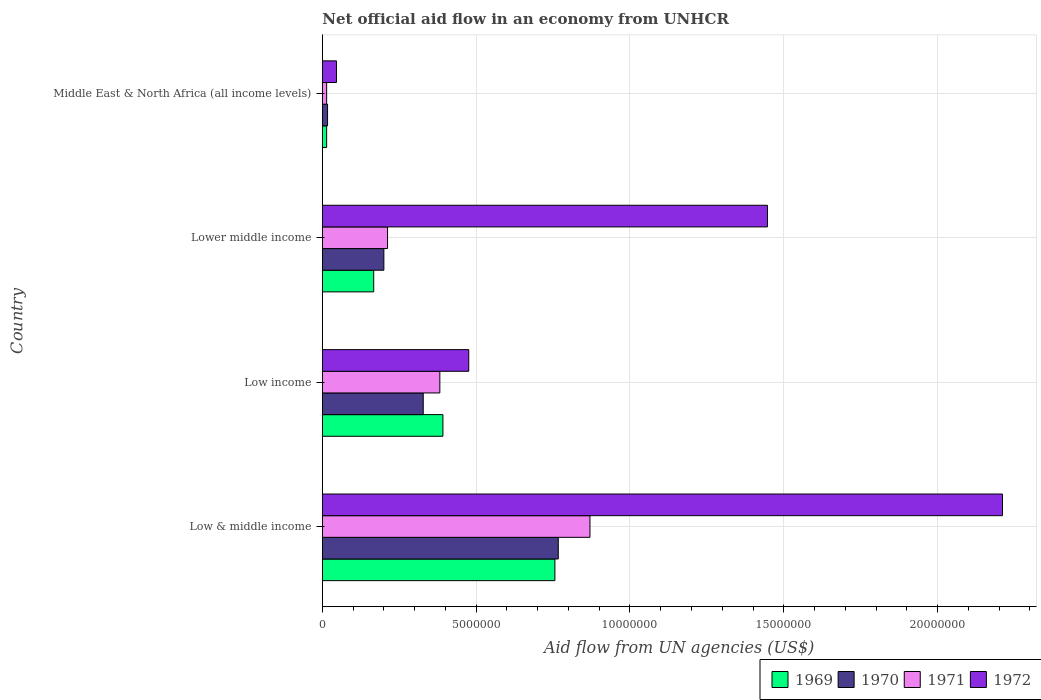How many different coloured bars are there?
Your response must be concise. 4. How many groups of bars are there?
Offer a terse response. 4. Are the number of bars on each tick of the Y-axis equal?
Provide a succinct answer. Yes. How many bars are there on the 2nd tick from the bottom?
Your answer should be very brief. 4. What is the net official aid flow in 1970 in Lower middle income?
Give a very brief answer. 2.00e+06. Across all countries, what is the maximum net official aid flow in 1972?
Ensure brevity in your answer.  2.21e+07. In which country was the net official aid flow in 1971 maximum?
Make the answer very short. Low & middle income. In which country was the net official aid flow in 1970 minimum?
Your answer should be compact. Middle East & North Africa (all income levels). What is the total net official aid flow in 1969 in the graph?
Provide a succinct answer. 1.33e+07. What is the difference between the net official aid flow in 1971 in Low & middle income and that in Low income?
Ensure brevity in your answer.  4.88e+06. What is the difference between the net official aid flow in 1970 in Middle East & North Africa (all income levels) and the net official aid flow in 1971 in Low & middle income?
Make the answer very short. -8.53e+06. What is the average net official aid flow in 1970 per country?
Provide a succinct answer. 3.28e+06. What is the difference between the net official aid flow in 1970 and net official aid flow in 1969 in Low income?
Offer a very short reply. -6.40e+05. In how many countries, is the net official aid flow in 1971 greater than 4000000 US$?
Offer a very short reply. 1. What is the ratio of the net official aid flow in 1970 in Low income to that in Middle East & North Africa (all income levels)?
Your answer should be very brief. 19.29. Is the net official aid flow in 1970 in Low & middle income less than that in Low income?
Your answer should be very brief. No. Is the difference between the net official aid flow in 1970 in Low income and Lower middle income greater than the difference between the net official aid flow in 1969 in Low income and Lower middle income?
Provide a short and direct response. No. What is the difference between the highest and the second highest net official aid flow in 1971?
Keep it short and to the point. 4.88e+06. What is the difference between the highest and the lowest net official aid flow in 1972?
Provide a succinct answer. 2.16e+07. Is it the case that in every country, the sum of the net official aid flow in 1971 and net official aid flow in 1972 is greater than the sum of net official aid flow in 1969 and net official aid flow in 1970?
Give a very brief answer. No. Is it the case that in every country, the sum of the net official aid flow in 1969 and net official aid flow in 1970 is greater than the net official aid flow in 1971?
Your answer should be compact. Yes. Are all the bars in the graph horizontal?
Your answer should be very brief. Yes. How many countries are there in the graph?
Provide a short and direct response. 4. Does the graph contain any zero values?
Keep it short and to the point. No. How many legend labels are there?
Your response must be concise. 4. What is the title of the graph?
Provide a short and direct response. Net official aid flow in an economy from UNHCR. Does "1960" appear as one of the legend labels in the graph?
Provide a succinct answer. No. What is the label or title of the X-axis?
Ensure brevity in your answer.  Aid flow from UN agencies (US$). What is the label or title of the Y-axis?
Ensure brevity in your answer.  Country. What is the Aid flow from UN agencies (US$) of 1969 in Low & middle income?
Your answer should be compact. 7.56e+06. What is the Aid flow from UN agencies (US$) of 1970 in Low & middle income?
Your answer should be very brief. 7.67e+06. What is the Aid flow from UN agencies (US$) of 1971 in Low & middle income?
Your answer should be very brief. 8.70e+06. What is the Aid flow from UN agencies (US$) in 1972 in Low & middle income?
Your answer should be compact. 2.21e+07. What is the Aid flow from UN agencies (US$) of 1969 in Low income?
Give a very brief answer. 3.92e+06. What is the Aid flow from UN agencies (US$) of 1970 in Low income?
Your response must be concise. 3.28e+06. What is the Aid flow from UN agencies (US$) in 1971 in Low income?
Make the answer very short. 3.82e+06. What is the Aid flow from UN agencies (US$) of 1972 in Low income?
Ensure brevity in your answer.  4.76e+06. What is the Aid flow from UN agencies (US$) in 1969 in Lower middle income?
Give a very brief answer. 1.67e+06. What is the Aid flow from UN agencies (US$) of 1970 in Lower middle income?
Your answer should be very brief. 2.00e+06. What is the Aid flow from UN agencies (US$) in 1971 in Lower middle income?
Give a very brief answer. 2.12e+06. What is the Aid flow from UN agencies (US$) of 1972 in Lower middle income?
Your answer should be very brief. 1.45e+07. What is the Aid flow from UN agencies (US$) of 1969 in Middle East & North Africa (all income levels)?
Ensure brevity in your answer.  1.40e+05. What is the Aid flow from UN agencies (US$) in 1970 in Middle East & North Africa (all income levels)?
Your response must be concise. 1.70e+05. What is the Aid flow from UN agencies (US$) of 1971 in Middle East & North Africa (all income levels)?
Your answer should be compact. 1.40e+05. Across all countries, what is the maximum Aid flow from UN agencies (US$) in 1969?
Offer a terse response. 7.56e+06. Across all countries, what is the maximum Aid flow from UN agencies (US$) in 1970?
Your answer should be compact. 7.67e+06. Across all countries, what is the maximum Aid flow from UN agencies (US$) of 1971?
Offer a very short reply. 8.70e+06. Across all countries, what is the maximum Aid flow from UN agencies (US$) in 1972?
Your response must be concise. 2.21e+07. Across all countries, what is the minimum Aid flow from UN agencies (US$) in 1970?
Offer a terse response. 1.70e+05. What is the total Aid flow from UN agencies (US$) in 1969 in the graph?
Your answer should be very brief. 1.33e+07. What is the total Aid flow from UN agencies (US$) of 1970 in the graph?
Offer a terse response. 1.31e+07. What is the total Aid flow from UN agencies (US$) in 1971 in the graph?
Make the answer very short. 1.48e+07. What is the total Aid flow from UN agencies (US$) of 1972 in the graph?
Keep it short and to the point. 4.18e+07. What is the difference between the Aid flow from UN agencies (US$) in 1969 in Low & middle income and that in Low income?
Your answer should be very brief. 3.64e+06. What is the difference between the Aid flow from UN agencies (US$) in 1970 in Low & middle income and that in Low income?
Ensure brevity in your answer.  4.39e+06. What is the difference between the Aid flow from UN agencies (US$) of 1971 in Low & middle income and that in Low income?
Make the answer very short. 4.88e+06. What is the difference between the Aid flow from UN agencies (US$) in 1972 in Low & middle income and that in Low income?
Keep it short and to the point. 1.74e+07. What is the difference between the Aid flow from UN agencies (US$) in 1969 in Low & middle income and that in Lower middle income?
Give a very brief answer. 5.89e+06. What is the difference between the Aid flow from UN agencies (US$) in 1970 in Low & middle income and that in Lower middle income?
Offer a very short reply. 5.67e+06. What is the difference between the Aid flow from UN agencies (US$) of 1971 in Low & middle income and that in Lower middle income?
Give a very brief answer. 6.58e+06. What is the difference between the Aid flow from UN agencies (US$) in 1972 in Low & middle income and that in Lower middle income?
Provide a succinct answer. 7.64e+06. What is the difference between the Aid flow from UN agencies (US$) of 1969 in Low & middle income and that in Middle East & North Africa (all income levels)?
Give a very brief answer. 7.42e+06. What is the difference between the Aid flow from UN agencies (US$) in 1970 in Low & middle income and that in Middle East & North Africa (all income levels)?
Your answer should be very brief. 7.50e+06. What is the difference between the Aid flow from UN agencies (US$) in 1971 in Low & middle income and that in Middle East & North Africa (all income levels)?
Your answer should be compact. 8.56e+06. What is the difference between the Aid flow from UN agencies (US$) in 1972 in Low & middle income and that in Middle East & North Africa (all income levels)?
Your response must be concise. 2.16e+07. What is the difference between the Aid flow from UN agencies (US$) of 1969 in Low income and that in Lower middle income?
Ensure brevity in your answer.  2.25e+06. What is the difference between the Aid flow from UN agencies (US$) of 1970 in Low income and that in Lower middle income?
Keep it short and to the point. 1.28e+06. What is the difference between the Aid flow from UN agencies (US$) of 1971 in Low income and that in Lower middle income?
Your response must be concise. 1.70e+06. What is the difference between the Aid flow from UN agencies (US$) of 1972 in Low income and that in Lower middle income?
Keep it short and to the point. -9.71e+06. What is the difference between the Aid flow from UN agencies (US$) in 1969 in Low income and that in Middle East & North Africa (all income levels)?
Your answer should be compact. 3.78e+06. What is the difference between the Aid flow from UN agencies (US$) of 1970 in Low income and that in Middle East & North Africa (all income levels)?
Provide a succinct answer. 3.11e+06. What is the difference between the Aid flow from UN agencies (US$) of 1971 in Low income and that in Middle East & North Africa (all income levels)?
Ensure brevity in your answer.  3.68e+06. What is the difference between the Aid flow from UN agencies (US$) of 1972 in Low income and that in Middle East & North Africa (all income levels)?
Offer a terse response. 4.30e+06. What is the difference between the Aid flow from UN agencies (US$) of 1969 in Lower middle income and that in Middle East & North Africa (all income levels)?
Ensure brevity in your answer.  1.53e+06. What is the difference between the Aid flow from UN agencies (US$) in 1970 in Lower middle income and that in Middle East & North Africa (all income levels)?
Your answer should be compact. 1.83e+06. What is the difference between the Aid flow from UN agencies (US$) of 1971 in Lower middle income and that in Middle East & North Africa (all income levels)?
Ensure brevity in your answer.  1.98e+06. What is the difference between the Aid flow from UN agencies (US$) of 1972 in Lower middle income and that in Middle East & North Africa (all income levels)?
Give a very brief answer. 1.40e+07. What is the difference between the Aid flow from UN agencies (US$) of 1969 in Low & middle income and the Aid flow from UN agencies (US$) of 1970 in Low income?
Offer a terse response. 4.28e+06. What is the difference between the Aid flow from UN agencies (US$) in 1969 in Low & middle income and the Aid flow from UN agencies (US$) in 1971 in Low income?
Your response must be concise. 3.74e+06. What is the difference between the Aid flow from UN agencies (US$) of 1969 in Low & middle income and the Aid flow from UN agencies (US$) of 1972 in Low income?
Offer a terse response. 2.80e+06. What is the difference between the Aid flow from UN agencies (US$) of 1970 in Low & middle income and the Aid flow from UN agencies (US$) of 1971 in Low income?
Provide a succinct answer. 3.85e+06. What is the difference between the Aid flow from UN agencies (US$) in 1970 in Low & middle income and the Aid flow from UN agencies (US$) in 1972 in Low income?
Your answer should be compact. 2.91e+06. What is the difference between the Aid flow from UN agencies (US$) of 1971 in Low & middle income and the Aid flow from UN agencies (US$) of 1972 in Low income?
Keep it short and to the point. 3.94e+06. What is the difference between the Aid flow from UN agencies (US$) of 1969 in Low & middle income and the Aid flow from UN agencies (US$) of 1970 in Lower middle income?
Provide a succinct answer. 5.56e+06. What is the difference between the Aid flow from UN agencies (US$) in 1969 in Low & middle income and the Aid flow from UN agencies (US$) in 1971 in Lower middle income?
Provide a short and direct response. 5.44e+06. What is the difference between the Aid flow from UN agencies (US$) of 1969 in Low & middle income and the Aid flow from UN agencies (US$) of 1972 in Lower middle income?
Make the answer very short. -6.91e+06. What is the difference between the Aid flow from UN agencies (US$) in 1970 in Low & middle income and the Aid flow from UN agencies (US$) in 1971 in Lower middle income?
Keep it short and to the point. 5.55e+06. What is the difference between the Aid flow from UN agencies (US$) in 1970 in Low & middle income and the Aid flow from UN agencies (US$) in 1972 in Lower middle income?
Keep it short and to the point. -6.80e+06. What is the difference between the Aid flow from UN agencies (US$) in 1971 in Low & middle income and the Aid flow from UN agencies (US$) in 1972 in Lower middle income?
Offer a terse response. -5.77e+06. What is the difference between the Aid flow from UN agencies (US$) in 1969 in Low & middle income and the Aid flow from UN agencies (US$) in 1970 in Middle East & North Africa (all income levels)?
Make the answer very short. 7.39e+06. What is the difference between the Aid flow from UN agencies (US$) in 1969 in Low & middle income and the Aid flow from UN agencies (US$) in 1971 in Middle East & North Africa (all income levels)?
Ensure brevity in your answer.  7.42e+06. What is the difference between the Aid flow from UN agencies (US$) in 1969 in Low & middle income and the Aid flow from UN agencies (US$) in 1972 in Middle East & North Africa (all income levels)?
Offer a very short reply. 7.10e+06. What is the difference between the Aid flow from UN agencies (US$) in 1970 in Low & middle income and the Aid flow from UN agencies (US$) in 1971 in Middle East & North Africa (all income levels)?
Make the answer very short. 7.53e+06. What is the difference between the Aid flow from UN agencies (US$) of 1970 in Low & middle income and the Aid flow from UN agencies (US$) of 1972 in Middle East & North Africa (all income levels)?
Your answer should be compact. 7.21e+06. What is the difference between the Aid flow from UN agencies (US$) of 1971 in Low & middle income and the Aid flow from UN agencies (US$) of 1972 in Middle East & North Africa (all income levels)?
Offer a very short reply. 8.24e+06. What is the difference between the Aid flow from UN agencies (US$) of 1969 in Low income and the Aid flow from UN agencies (US$) of 1970 in Lower middle income?
Make the answer very short. 1.92e+06. What is the difference between the Aid flow from UN agencies (US$) of 1969 in Low income and the Aid flow from UN agencies (US$) of 1971 in Lower middle income?
Offer a very short reply. 1.80e+06. What is the difference between the Aid flow from UN agencies (US$) of 1969 in Low income and the Aid flow from UN agencies (US$) of 1972 in Lower middle income?
Your response must be concise. -1.06e+07. What is the difference between the Aid flow from UN agencies (US$) of 1970 in Low income and the Aid flow from UN agencies (US$) of 1971 in Lower middle income?
Your response must be concise. 1.16e+06. What is the difference between the Aid flow from UN agencies (US$) of 1970 in Low income and the Aid flow from UN agencies (US$) of 1972 in Lower middle income?
Keep it short and to the point. -1.12e+07. What is the difference between the Aid flow from UN agencies (US$) of 1971 in Low income and the Aid flow from UN agencies (US$) of 1972 in Lower middle income?
Provide a succinct answer. -1.06e+07. What is the difference between the Aid flow from UN agencies (US$) in 1969 in Low income and the Aid flow from UN agencies (US$) in 1970 in Middle East & North Africa (all income levels)?
Ensure brevity in your answer.  3.75e+06. What is the difference between the Aid flow from UN agencies (US$) of 1969 in Low income and the Aid flow from UN agencies (US$) of 1971 in Middle East & North Africa (all income levels)?
Make the answer very short. 3.78e+06. What is the difference between the Aid flow from UN agencies (US$) of 1969 in Low income and the Aid flow from UN agencies (US$) of 1972 in Middle East & North Africa (all income levels)?
Your answer should be very brief. 3.46e+06. What is the difference between the Aid flow from UN agencies (US$) of 1970 in Low income and the Aid flow from UN agencies (US$) of 1971 in Middle East & North Africa (all income levels)?
Keep it short and to the point. 3.14e+06. What is the difference between the Aid flow from UN agencies (US$) of 1970 in Low income and the Aid flow from UN agencies (US$) of 1972 in Middle East & North Africa (all income levels)?
Give a very brief answer. 2.82e+06. What is the difference between the Aid flow from UN agencies (US$) of 1971 in Low income and the Aid flow from UN agencies (US$) of 1972 in Middle East & North Africa (all income levels)?
Ensure brevity in your answer.  3.36e+06. What is the difference between the Aid flow from UN agencies (US$) in 1969 in Lower middle income and the Aid flow from UN agencies (US$) in 1970 in Middle East & North Africa (all income levels)?
Offer a terse response. 1.50e+06. What is the difference between the Aid flow from UN agencies (US$) in 1969 in Lower middle income and the Aid flow from UN agencies (US$) in 1971 in Middle East & North Africa (all income levels)?
Give a very brief answer. 1.53e+06. What is the difference between the Aid flow from UN agencies (US$) in 1969 in Lower middle income and the Aid flow from UN agencies (US$) in 1972 in Middle East & North Africa (all income levels)?
Make the answer very short. 1.21e+06. What is the difference between the Aid flow from UN agencies (US$) in 1970 in Lower middle income and the Aid flow from UN agencies (US$) in 1971 in Middle East & North Africa (all income levels)?
Your answer should be very brief. 1.86e+06. What is the difference between the Aid flow from UN agencies (US$) of 1970 in Lower middle income and the Aid flow from UN agencies (US$) of 1972 in Middle East & North Africa (all income levels)?
Keep it short and to the point. 1.54e+06. What is the difference between the Aid flow from UN agencies (US$) in 1971 in Lower middle income and the Aid flow from UN agencies (US$) in 1972 in Middle East & North Africa (all income levels)?
Make the answer very short. 1.66e+06. What is the average Aid flow from UN agencies (US$) of 1969 per country?
Make the answer very short. 3.32e+06. What is the average Aid flow from UN agencies (US$) of 1970 per country?
Provide a succinct answer. 3.28e+06. What is the average Aid flow from UN agencies (US$) in 1971 per country?
Keep it short and to the point. 3.70e+06. What is the average Aid flow from UN agencies (US$) in 1972 per country?
Your response must be concise. 1.04e+07. What is the difference between the Aid flow from UN agencies (US$) of 1969 and Aid flow from UN agencies (US$) of 1970 in Low & middle income?
Make the answer very short. -1.10e+05. What is the difference between the Aid flow from UN agencies (US$) in 1969 and Aid flow from UN agencies (US$) in 1971 in Low & middle income?
Provide a succinct answer. -1.14e+06. What is the difference between the Aid flow from UN agencies (US$) of 1969 and Aid flow from UN agencies (US$) of 1972 in Low & middle income?
Keep it short and to the point. -1.46e+07. What is the difference between the Aid flow from UN agencies (US$) in 1970 and Aid flow from UN agencies (US$) in 1971 in Low & middle income?
Ensure brevity in your answer.  -1.03e+06. What is the difference between the Aid flow from UN agencies (US$) in 1970 and Aid flow from UN agencies (US$) in 1972 in Low & middle income?
Ensure brevity in your answer.  -1.44e+07. What is the difference between the Aid flow from UN agencies (US$) of 1971 and Aid flow from UN agencies (US$) of 1972 in Low & middle income?
Provide a succinct answer. -1.34e+07. What is the difference between the Aid flow from UN agencies (US$) of 1969 and Aid flow from UN agencies (US$) of 1970 in Low income?
Ensure brevity in your answer.  6.40e+05. What is the difference between the Aid flow from UN agencies (US$) in 1969 and Aid flow from UN agencies (US$) in 1972 in Low income?
Provide a succinct answer. -8.40e+05. What is the difference between the Aid flow from UN agencies (US$) in 1970 and Aid flow from UN agencies (US$) in 1971 in Low income?
Provide a short and direct response. -5.40e+05. What is the difference between the Aid flow from UN agencies (US$) in 1970 and Aid flow from UN agencies (US$) in 1972 in Low income?
Provide a short and direct response. -1.48e+06. What is the difference between the Aid flow from UN agencies (US$) in 1971 and Aid flow from UN agencies (US$) in 1972 in Low income?
Make the answer very short. -9.40e+05. What is the difference between the Aid flow from UN agencies (US$) in 1969 and Aid flow from UN agencies (US$) in 1970 in Lower middle income?
Your answer should be very brief. -3.30e+05. What is the difference between the Aid flow from UN agencies (US$) of 1969 and Aid flow from UN agencies (US$) of 1971 in Lower middle income?
Your answer should be compact. -4.50e+05. What is the difference between the Aid flow from UN agencies (US$) in 1969 and Aid flow from UN agencies (US$) in 1972 in Lower middle income?
Provide a succinct answer. -1.28e+07. What is the difference between the Aid flow from UN agencies (US$) of 1970 and Aid flow from UN agencies (US$) of 1972 in Lower middle income?
Make the answer very short. -1.25e+07. What is the difference between the Aid flow from UN agencies (US$) in 1971 and Aid flow from UN agencies (US$) in 1972 in Lower middle income?
Offer a very short reply. -1.24e+07. What is the difference between the Aid flow from UN agencies (US$) of 1969 and Aid flow from UN agencies (US$) of 1972 in Middle East & North Africa (all income levels)?
Provide a succinct answer. -3.20e+05. What is the difference between the Aid flow from UN agencies (US$) in 1971 and Aid flow from UN agencies (US$) in 1972 in Middle East & North Africa (all income levels)?
Your response must be concise. -3.20e+05. What is the ratio of the Aid flow from UN agencies (US$) in 1969 in Low & middle income to that in Low income?
Make the answer very short. 1.93. What is the ratio of the Aid flow from UN agencies (US$) in 1970 in Low & middle income to that in Low income?
Your response must be concise. 2.34. What is the ratio of the Aid flow from UN agencies (US$) in 1971 in Low & middle income to that in Low income?
Make the answer very short. 2.28. What is the ratio of the Aid flow from UN agencies (US$) in 1972 in Low & middle income to that in Low income?
Ensure brevity in your answer.  4.64. What is the ratio of the Aid flow from UN agencies (US$) in 1969 in Low & middle income to that in Lower middle income?
Provide a succinct answer. 4.53. What is the ratio of the Aid flow from UN agencies (US$) in 1970 in Low & middle income to that in Lower middle income?
Provide a short and direct response. 3.83. What is the ratio of the Aid flow from UN agencies (US$) of 1971 in Low & middle income to that in Lower middle income?
Make the answer very short. 4.1. What is the ratio of the Aid flow from UN agencies (US$) of 1972 in Low & middle income to that in Lower middle income?
Ensure brevity in your answer.  1.53. What is the ratio of the Aid flow from UN agencies (US$) in 1969 in Low & middle income to that in Middle East & North Africa (all income levels)?
Provide a short and direct response. 54. What is the ratio of the Aid flow from UN agencies (US$) in 1970 in Low & middle income to that in Middle East & North Africa (all income levels)?
Offer a terse response. 45.12. What is the ratio of the Aid flow from UN agencies (US$) of 1971 in Low & middle income to that in Middle East & North Africa (all income levels)?
Provide a short and direct response. 62.14. What is the ratio of the Aid flow from UN agencies (US$) in 1972 in Low & middle income to that in Middle East & North Africa (all income levels)?
Give a very brief answer. 48.07. What is the ratio of the Aid flow from UN agencies (US$) of 1969 in Low income to that in Lower middle income?
Offer a terse response. 2.35. What is the ratio of the Aid flow from UN agencies (US$) in 1970 in Low income to that in Lower middle income?
Offer a terse response. 1.64. What is the ratio of the Aid flow from UN agencies (US$) in 1971 in Low income to that in Lower middle income?
Offer a very short reply. 1.8. What is the ratio of the Aid flow from UN agencies (US$) of 1972 in Low income to that in Lower middle income?
Offer a very short reply. 0.33. What is the ratio of the Aid flow from UN agencies (US$) of 1970 in Low income to that in Middle East & North Africa (all income levels)?
Your answer should be very brief. 19.29. What is the ratio of the Aid flow from UN agencies (US$) of 1971 in Low income to that in Middle East & North Africa (all income levels)?
Your response must be concise. 27.29. What is the ratio of the Aid flow from UN agencies (US$) of 1972 in Low income to that in Middle East & North Africa (all income levels)?
Ensure brevity in your answer.  10.35. What is the ratio of the Aid flow from UN agencies (US$) of 1969 in Lower middle income to that in Middle East & North Africa (all income levels)?
Offer a terse response. 11.93. What is the ratio of the Aid flow from UN agencies (US$) in 1970 in Lower middle income to that in Middle East & North Africa (all income levels)?
Give a very brief answer. 11.76. What is the ratio of the Aid flow from UN agencies (US$) in 1971 in Lower middle income to that in Middle East & North Africa (all income levels)?
Offer a terse response. 15.14. What is the ratio of the Aid flow from UN agencies (US$) of 1972 in Lower middle income to that in Middle East & North Africa (all income levels)?
Give a very brief answer. 31.46. What is the difference between the highest and the second highest Aid flow from UN agencies (US$) of 1969?
Keep it short and to the point. 3.64e+06. What is the difference between the highest and the second highest Aid flow from UN agencies (US$) in 1970?
Your answer should be compact. 4.39e+06. What is the difference between the highest and the second highest Aid flow from UN agencies (US$) in 1971?
Ensure brevity in your answer.  4.88e+06. What is the difference between the highest and the second highest Aid flow from UN agencies (US$) of 1972?
Provide a short and direct response. 7.64e+06. What is the difference between the highest and the lowest Aid flow from UN agencies (US$) in 1969?
Offer a very short reply. 7.42e+06. What is the difference between the highest and the lowest Aid flow from UN agencies (US$) in 1970?
Offer a very short reply. 7.50e+06. What is the difference between the highest and the lowest Aid flow from UN agencies (US$) of 1971?
Make the answer very short. 8.56e+06. What is the difference between the highest and the lowest Aid flow from UN agencies (US$) of 1972?
Your answer should be compact. 2.16e+07. 